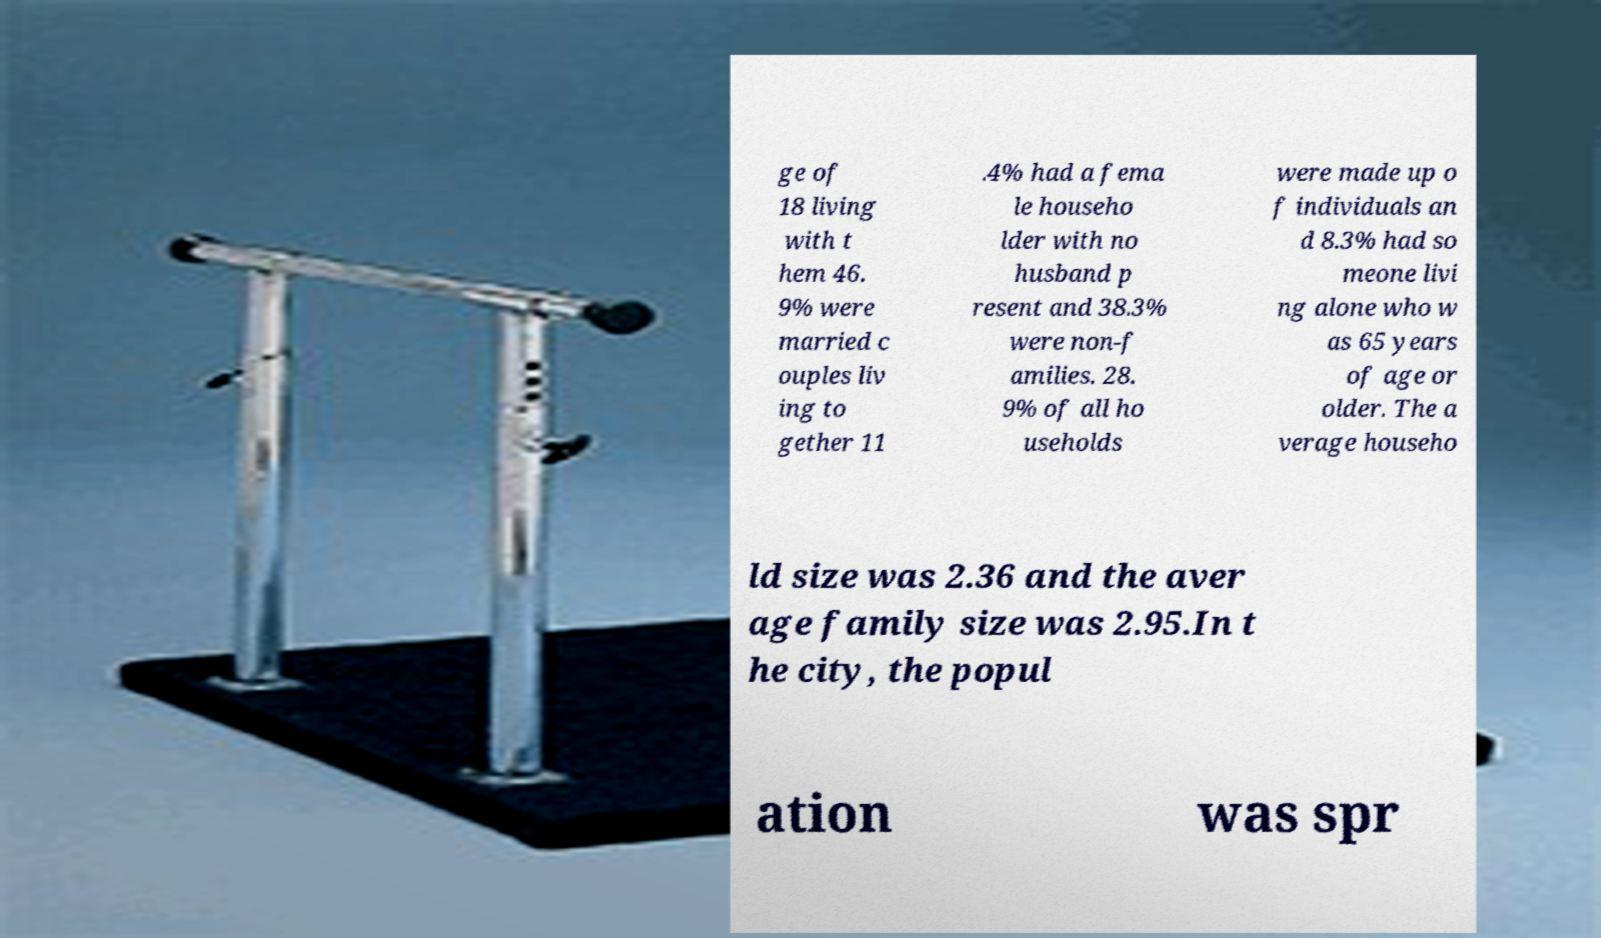I need the written content from this picture converted into text. Can you do that? ge of 18 living with t hem 46. 9% were married c ouples liv ing to gether 11 .4% had a fema le househo lder with no husband p resent and 38.3% were non-f amilies. 28. 9% of all ho useholds were made up o f individuals an d 8.3% had so meone livi ng alone who w as 65 years of age or older. The a verage househo ld size was 2.36 and the aver age family size was 2.95.In t he city, the popul ation was spr 